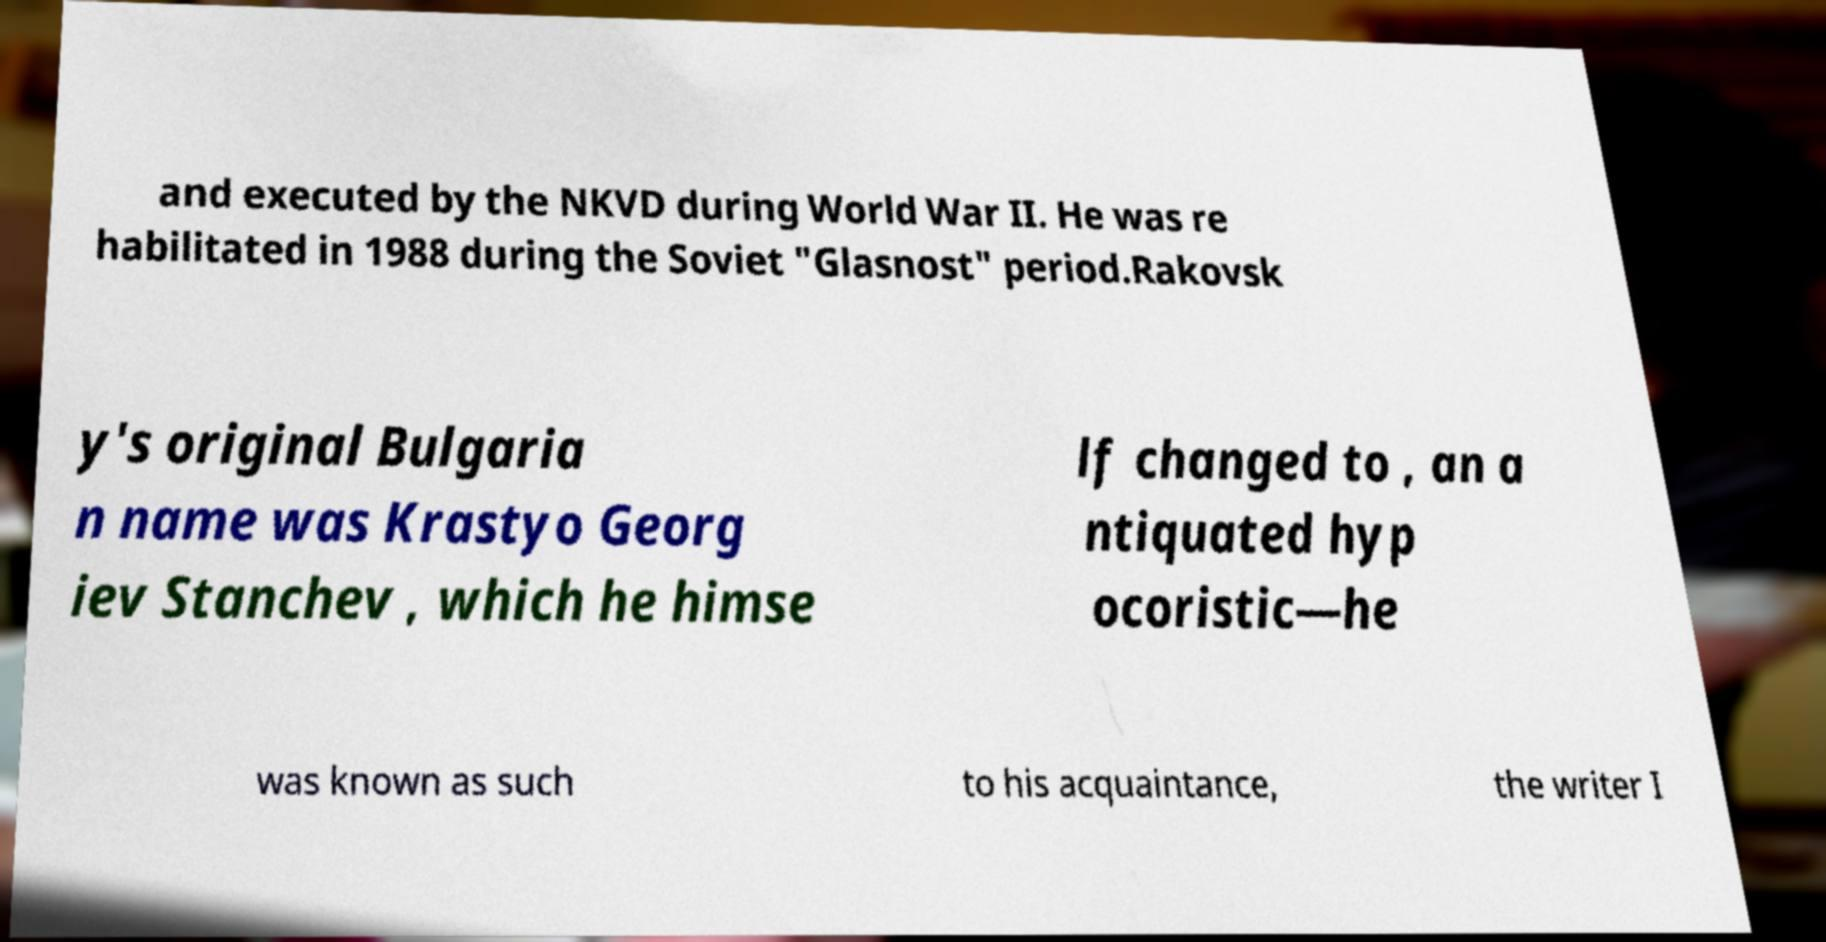I need the written content from this picture converted into text. Can you do that? and executed by the NKVD during World War II. He was re habilitated in 1988 during the Soviet "Glasnost" period.Rakovsk y's original Bulgaria n name was Krastyo Georg iev Stanchev , which he himse lf changed to , an a ntiquated hyp ocoristic—he was known as such to his acquaintance, the writer I 